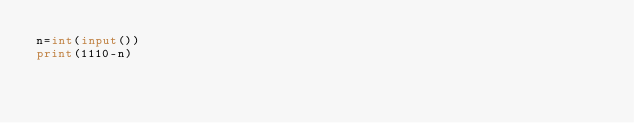Convert code to text. <code><loc_0><loc_0><loc_500><loc_500><_Python_>n=int(input())
print(1110-n)
</code> 